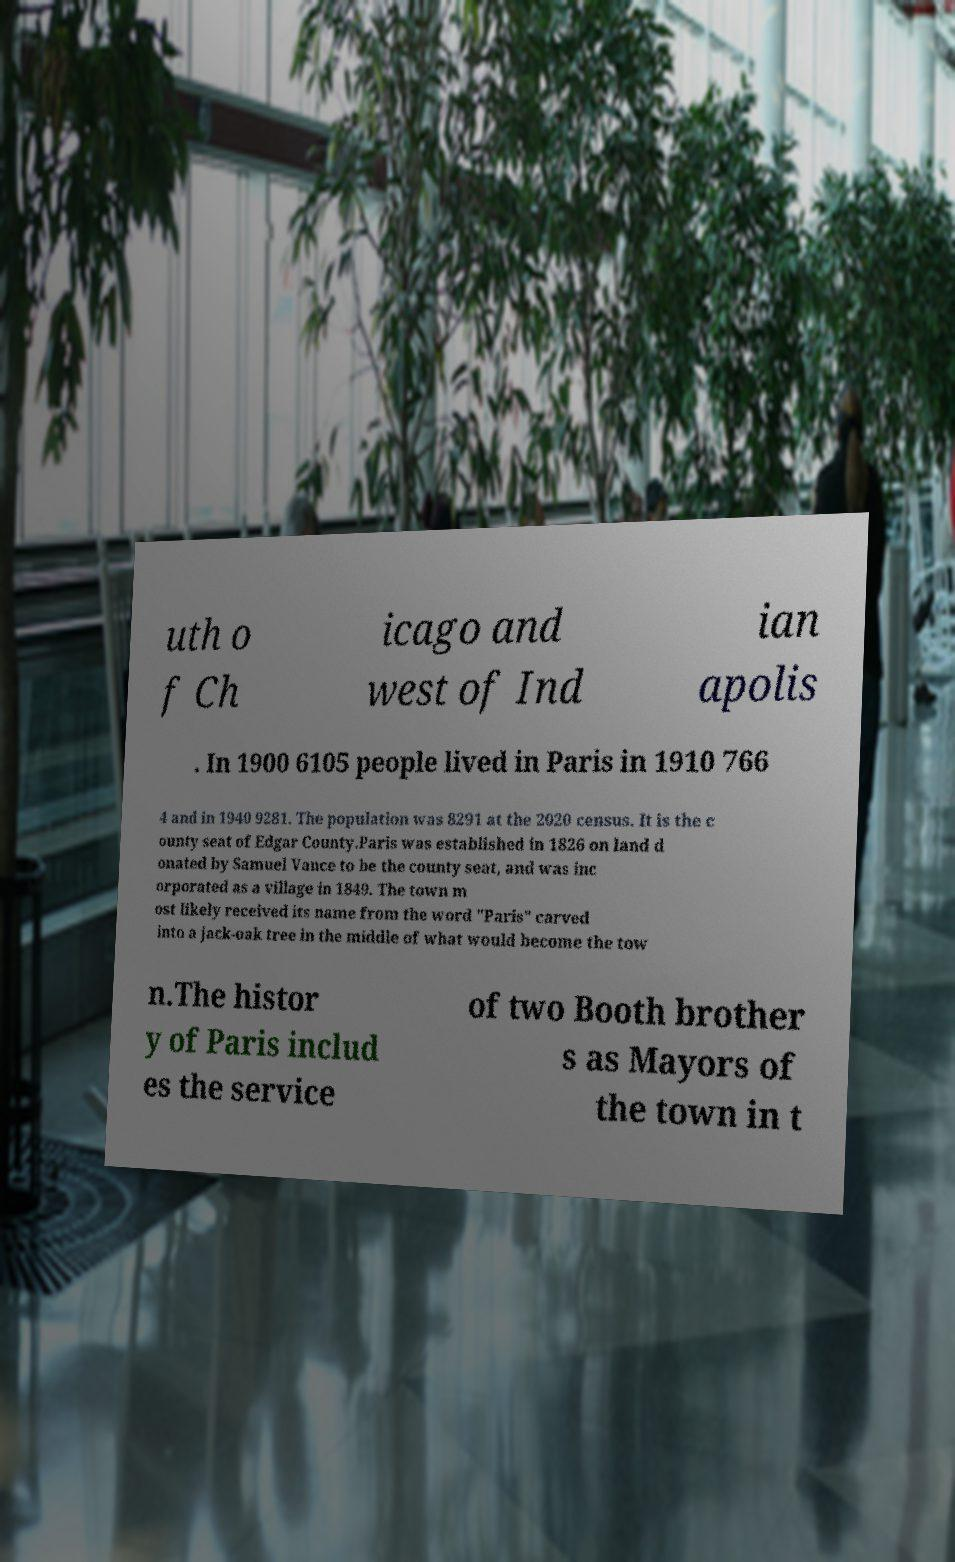Can you read and provide the text displayed in the image?This photo seems to have some interesting text. Can you extract and type it out for me? uth o f Ch icago and west of Ind ian apolis . In 1900 6105 people lived in Paris in 1910 766 4 and in 1940 9281. The population was 8291 at the 2020 census. It is the c ounty seat of Edgar County.Paris was established in 1826 on land d onated by Samuel Vance to be the county seat, and was inc orporated as a village in 1849. The town m ost likely received its name from the word "Paris" carved into a jack-oak tree in the middle of what would become the tow n.The histor y of Paris includ es the service of two Booth brother s as Mayors of the town in t 